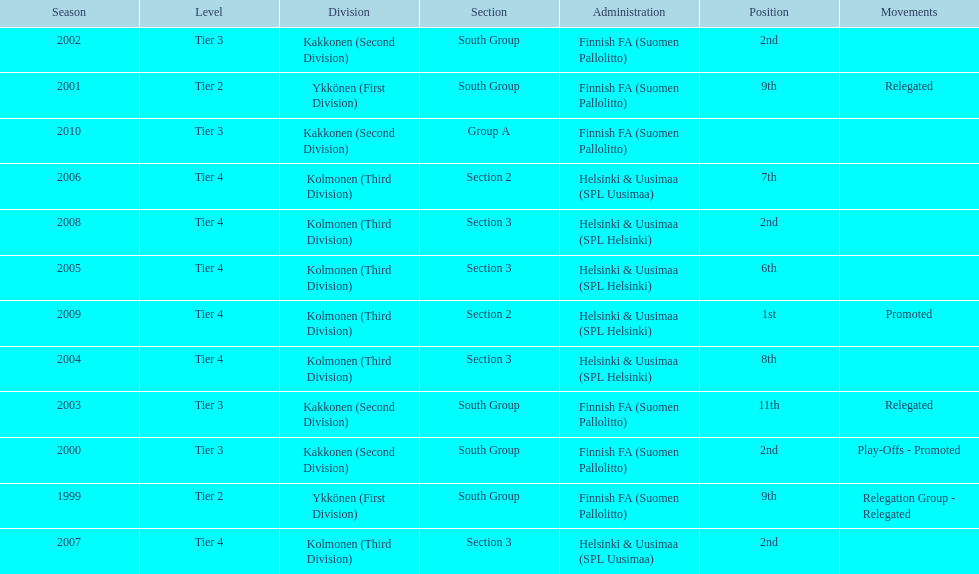What spot did this team reach after getting 9th place in 1999? 2nd. 